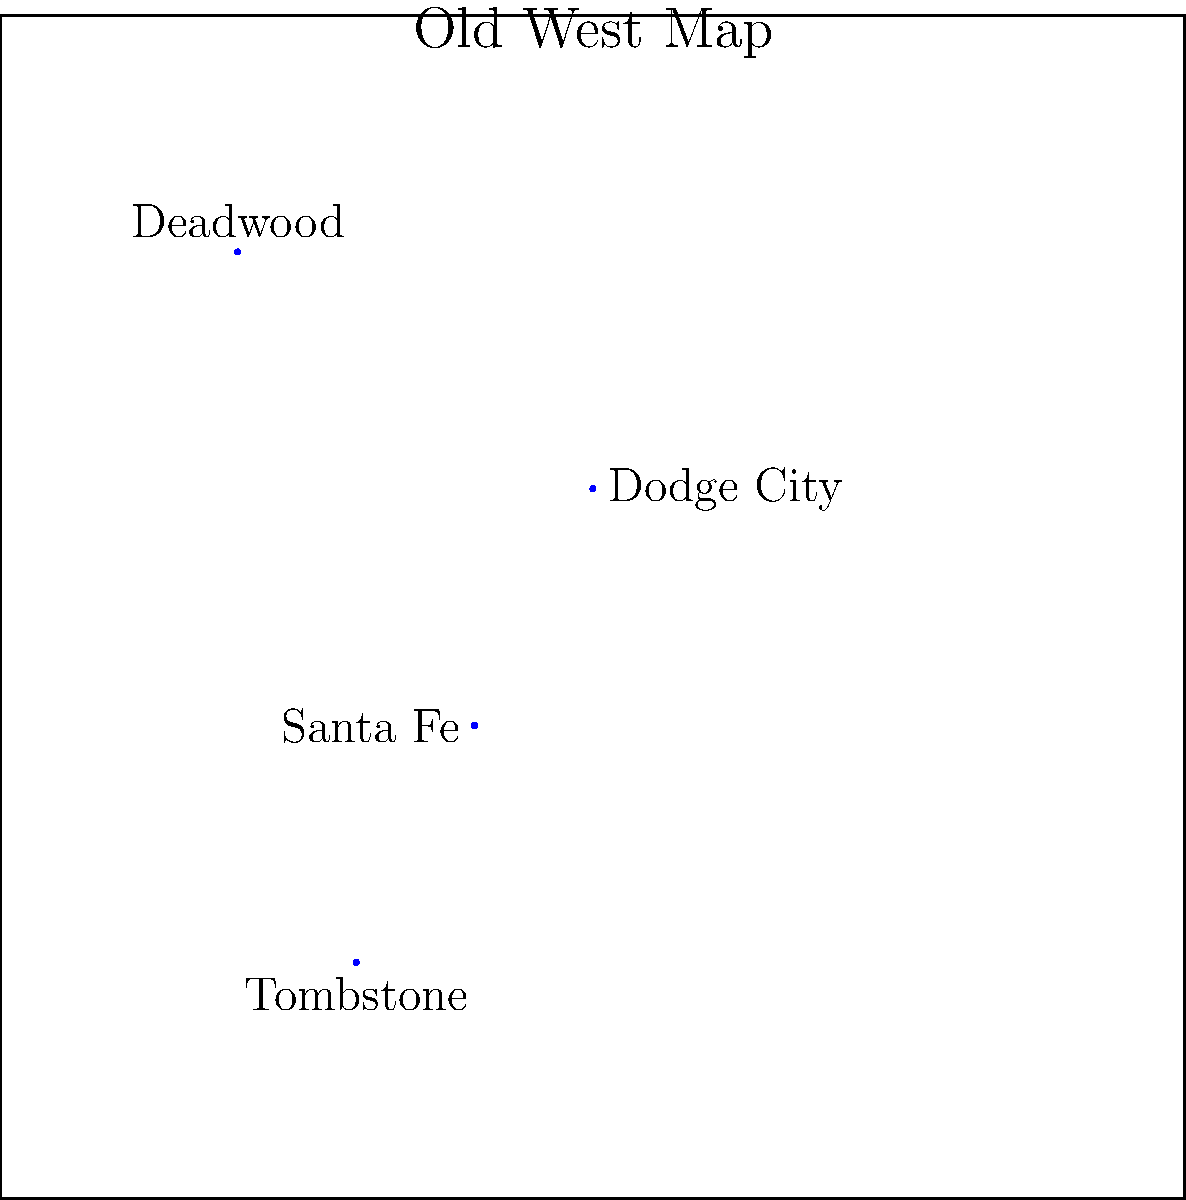Based on the map of key locations in the American Old West, which city is located furthest south? To determine which city is located furthest south on the map, we need to compare the vertical positions of all the cities:

1. Deadwood: Located near the top of the map
2. Tombstone: Positioned at the bottom of the map
3. Dodge City: Situated in the upper-middle area
4. Santa Fe: Found in the center-lower portion

When analyzing the vertical axis:
- Deadwood has the highest position
- Dodge City is the second highest
- Santa Fe is lower than Dodge City but higher than Tombstone
- Tombstone has the lowest vertical position

Therefore, Tombstone is located furthest south on this map of the American Old West.
Answer: Tombstone 